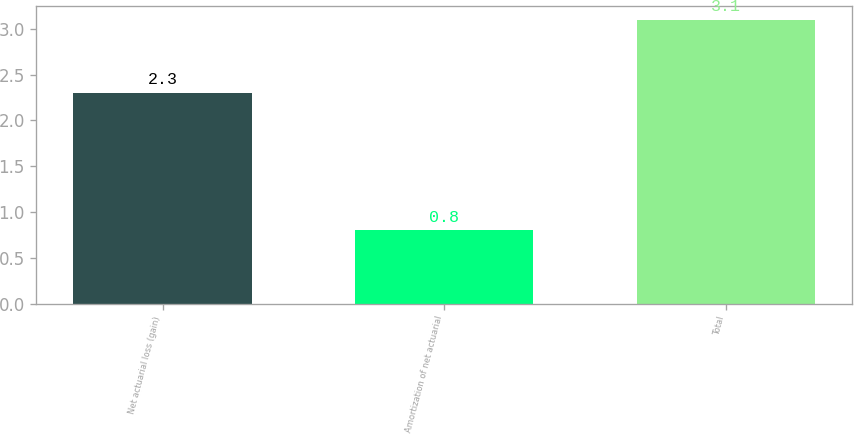<chart> <loc_0><loc_0><loc_500><loc_500><bar_chart><fcel>Net actuarial loss (gain)<fcel>Amortization of net actuarial<fcel>Total<nl><fcel>2.3<fcel>0.8<fcel>3.1<nl></chart> 